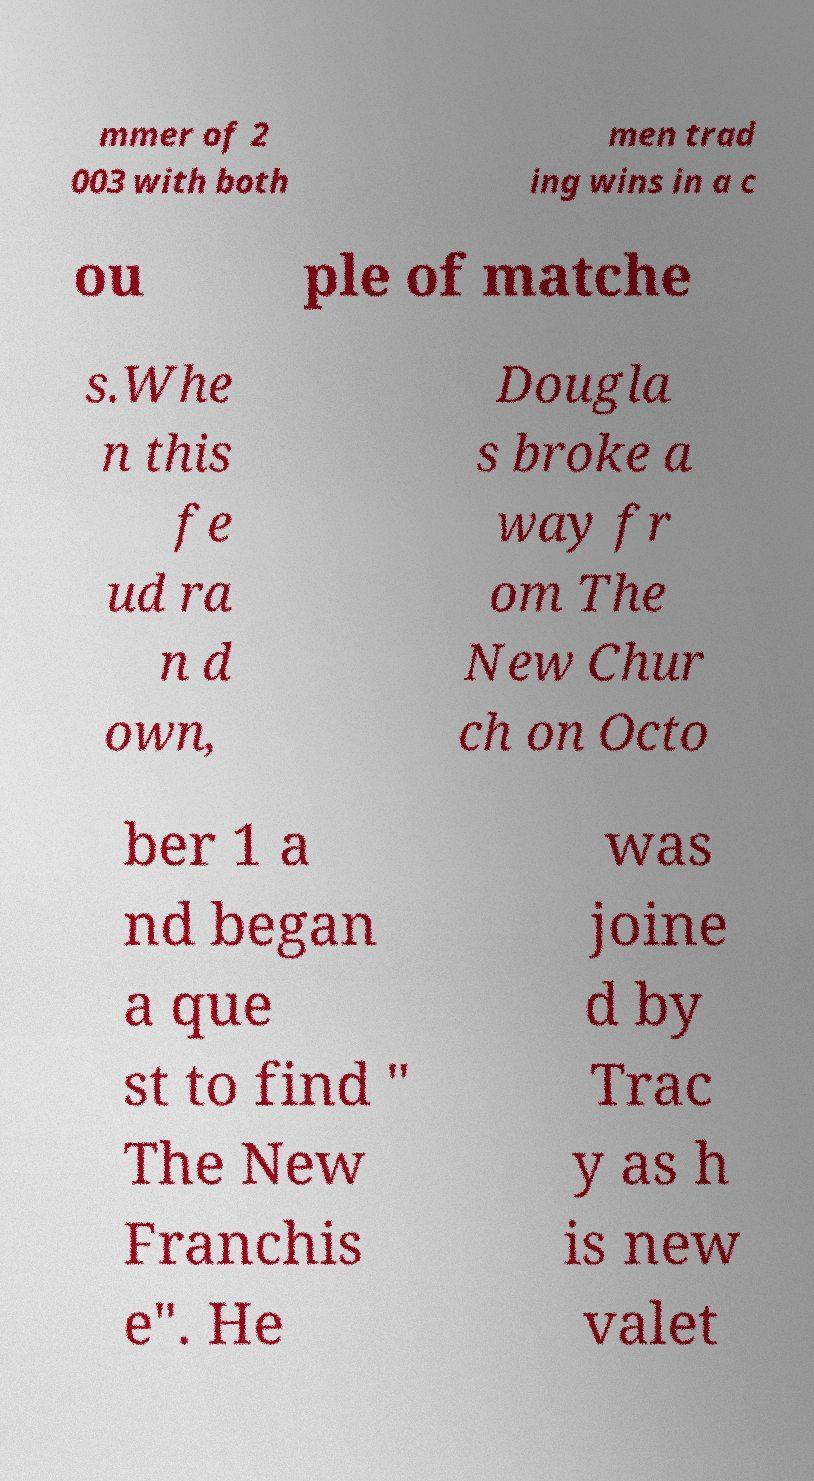I need the written content from this picture converted into text. Can you do that? mmer of 2 003 with both men trad ing wins in a c ou ple of matche s.Whe n this fe ud ra n d own, Dougla s broke a way fr om The New Chur ch on Octo ber 1 a nd began a que st to find " The New Franchis e". He was joine d by Trac y as h is new valet 